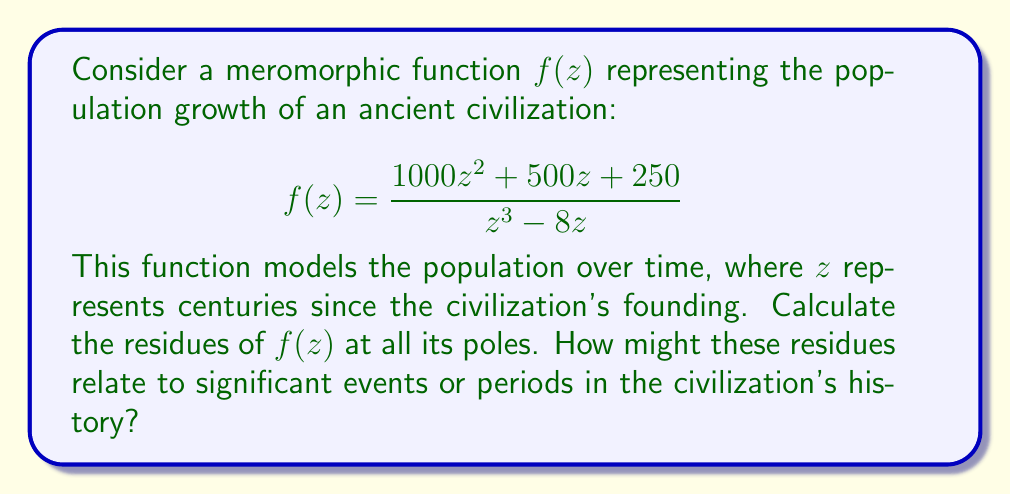Help me with this question. To calculate the residues of $f(z)$, we need to follow these steps:

1. Identify the poles of $f(z)$:
   The poles are the roots of the denominator: $z^3 - 8z = z(z^2 - 8) = z(z-2\sqrt{2})(z+2\sqrt{2})$
   So, the poles are at $z = 0$, $z = 2\sqrt{2}$, and $z = -2\sqrt{2}$

2. Determine the order of each pole:
   All poles are simple (order 1) as they appear only once in the factorization.

3. Calculate the residues:

   For simple poles, we use the formula: $\text{Res}(f, a) = \lim_{z \to a} (z-a)f(z)$

   a) At $z = 0$:
      $$\text{Res}(f, 0) = \lim_{z \to 0} z \cdot \frac{1000z^2 + 500z + 250}{z^3 - 8z} = \lim_{z \to 0} \frac{1000z^2 + 500z + 250}{z^2 - 8} = -\frac{250}{8} = -31.25$$

   b) At $z = 2\sqrt{2}$:
      $$\text{Res}(f, 2\sqrt{2}) = \lim_{z \to 2\sqrt{2}} (z-2\sqrt{2}) \cdot \frac{1000z^2 + 500z + 250}{z^3 - 8z}$$
      $$= \frac{1000(2\sqrt{2})^2 + 500(2\sqrt{2}) + 250}{3(2\sqrt{2})^2 - 8} = \frac{4000 + 1000\sqrt{2} + 250}{24 - 8} = \frac{4250 + 1000\sqrt{2}}{16} = 265.625 + 62.5\sqrt{2}$$

   c) At $z = -2\sqrt{2}$:
      $$\text{Res}(f, -2\sqrt{2}) = \lim_{z \to -2\sqrt{2}} (z+2\sqrt{2}) \cdot \frac{1000z^2 + 500z + 250}{z^3 - 8z}$$
      $$= \frac{1000(2\sqrt{2})^2 - 500(2\sqrt{2}) + 250}{3(2\sqrt{2})^2 - 8} = \frac{4000 - 1000\sqrt{2} + 250}{24 - 8} = \frac{4250 - 1000\sqrt{2}}{16} = 265.625 - 62.5\sqrt{2}$$

These residues could be interpreted in the context of historical events:
- The negative residue at $z = 0$ might represent initial population decline or challenges in the early stages of the civilization.
- The positive residues at $z = \pm 2\sqrt{2}$ could indicate periods of significant growth or prosperity, possibly linked to technological advancements or expansions.
- The symmetric nature of the residues at $z = \pm 2\sqrt{2}$ might suggest cyclical patterns in the civilization's history.
Answer: The residues of $f(z)$ are:
$$\text{Res}(f, 0) = -31.25$$
$$\text{Res}(f, 2\sqrt{2}) = 265.625 + 62.5\sqrt{2}$$
$$\text{Res}(f, -2\sqrt{2}) = 265.625 - 62.5\sqrt{2}$$ 